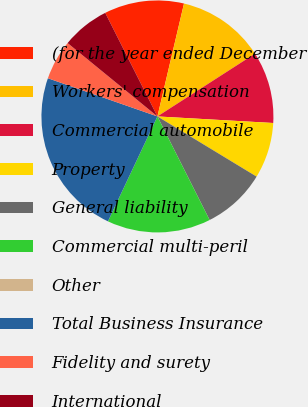Convert chart. <chart><loc_0><loc_0><loc_500><loc_500><pie_chart><fcel>(for the year ended December<fcel>Workers' compensation<fcel>Commercial automobile<fcel>Property<fcel>General liability<fcel>Commercial multi-peril<fcel>Other<fcel>Total Business Insurance<fcel>Fidelity and surety<fcel>International<nl><fcel>11.11%<fcel>12.22%<fcel>10.0%<fcel>7.78%<fcel>8.89%<fcel>14.44%<fcel>0.0%<fcel>23.33%<fcel>5.56%<fcel>6.67%<nl></chart> 